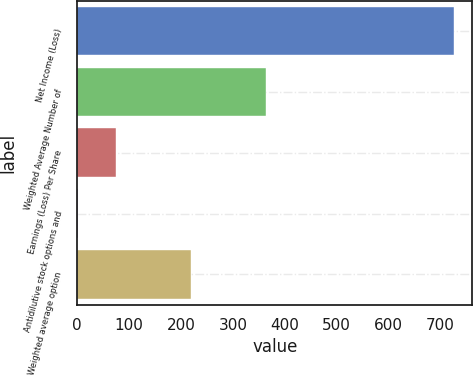Convert chart to OTSL. <chart><loc_0><loc_0><loc_500><loc_500><bar_chart><fcel>Net Income (Loss)<fcel>Weighted Average Number of<fcel>Earnings (Loss) Per Share<fcel>Antidilutive stock options and<fcel>Weighted average option<nl><fcel>725<fcel>363.5<fcel>74.3<fcel>2<fcel>218.9<nl></chart> 